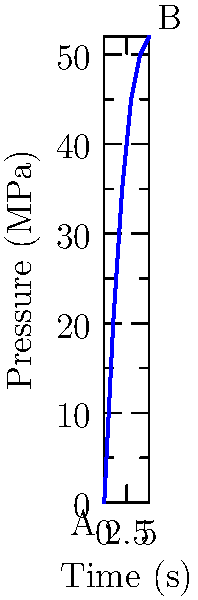In designing a hydraulic system for raising and lowering large set pieces, the pressure-time curve for the system startup is shown above. What is the average rate of pressure increase in the system between points A and B? To find the average rate of pressure increase, we need to follow these steps:

1. Identify the initial and final points:
   Point A: (0 s, 0 MPa)
   Point B: (5 s, 52 MPa)

2. Calculate the change in pressure (Δp):
   Δp = 52 MPa - 0 MPa = 52 MPa

3. Calculate the change in time (Δt):
   Δt = 5 s - 0 s = 5 s

4. Use the formula for average rate of change:
   Average rate = Δp / Δt

5. Substitute the values:
   Average rate = 52 MPa / 5 s = 10.4 MPa/s

Therefore, the average rate of pressure increase in the system between points A and B is 10.4 MPa/s.
Answer: 10.4 MPa/s 